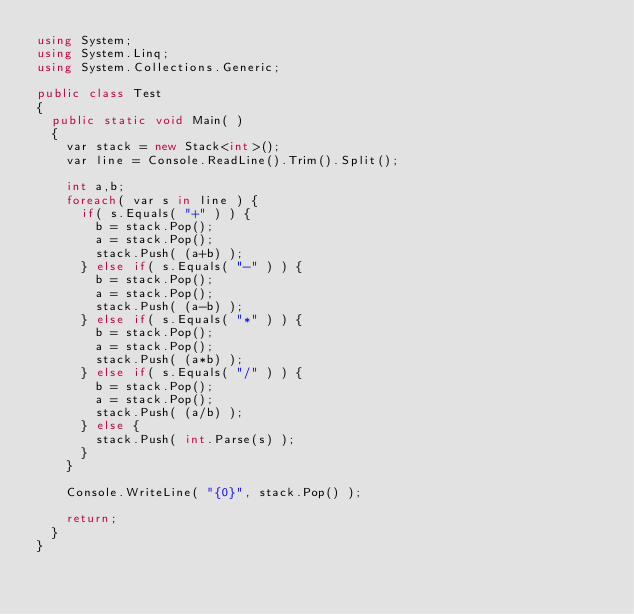Convert code to text. <code><loc_0><loc_0><loc_500><loc_500><_C#_>using System;
using System.Linq;
using System.Collections.Generic;

public class Test
{
	public static void Main( )
	{
		var stack = new Stack<int>();
		var line = Console.ReadLine().Trim().Split();
		
		int a,b;
		foreach( var s in line ) {
			if( s.Equals( "+" ) ) {
				b = stack.Pop();
				a = stack.Pop();
				stack.Push( (a+b) );
			} else if( s.Equals( "-" ) ) {
				b = stack.Pop();
				a = stack.Pop();
				stack.Push( (a-b) );
			} else if( s.Equals( "*" ) ) {
				b = stack.Pop();
				a = stack.Pop();
				stack.Push( (a*b) );
			} else if( s.Equals( "/" ) ) {
				b = stack.Pop();
				a = stack.Pop();
				stack.Push( (a/b) );
			} else {
				stack.Push( int.Parse(s) );
			}
		}
		
		Console.WriteLine( "{0}", stack.Pop() );

		return;
	}
}
</code> 